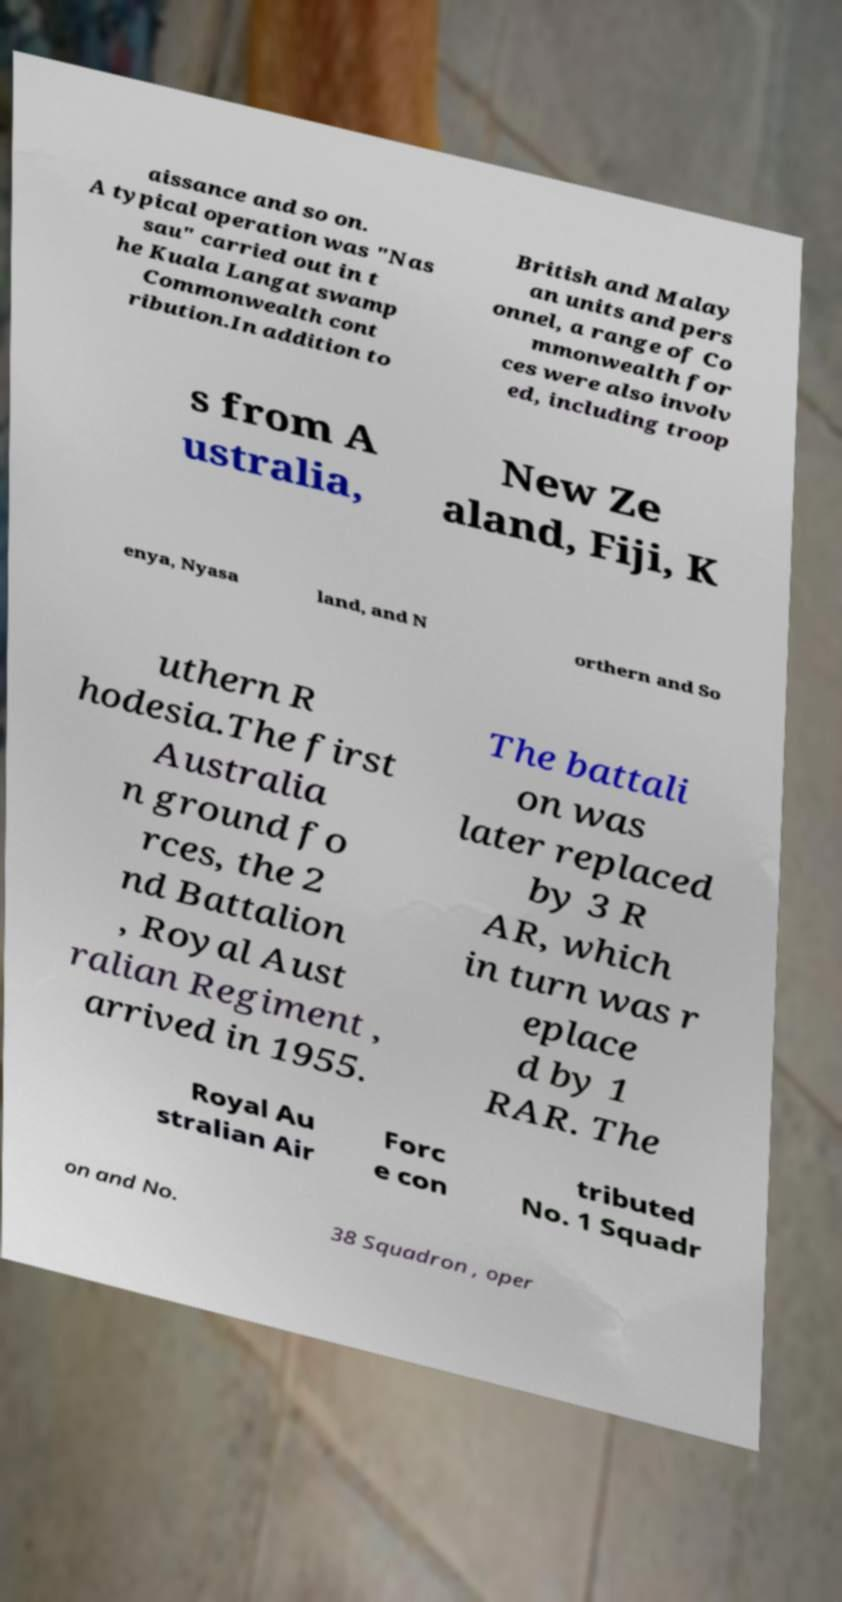What messages or text are displayed in this image? I need them in a readable, typed format. aissance and so on. A typical operation was "Nas sau" carried out in t he Kuala Langat swamp Commonwealth cont ribution.In addition to British and Malay an units and pers onnel, a range of Co mmonwealth for ces were also involv ed, including troop s from A ustralia, New Ze aland, Fiji, K enya, Nyasa land, and N orthern and So uthern R hodesia.The first Australia n ground fo rces, the 2 nd Battalion , Royal Aust ralian Regiment , arrived in 1955. The battali on was later replaced by 3 R AR, which in turn was r eplace d by 1 RAR. The Royal Au stralian Air Forc e con tributed No. 1 Squadr on and No. 38 Squadron , oper 